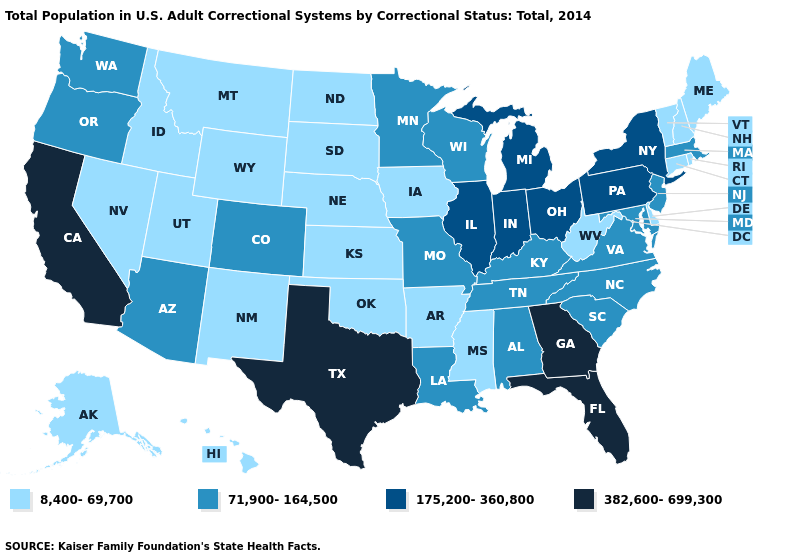What is the value of Florida?
Concise answer only. 382,600-699,300. What is the lowest value in the USA?
Concise answer only. 8,400-69,700. What is the lowest value in the South?
Concise answer only. 8,400-69,700. Which states have the lowest value in the MidWest?
Answer briefly. Iowa, Kansas, Nebraska, North Dakota, South Dakota. What is the value of Alabama?
Short answer required. 71,900-164,500. What is the value of Hawaii?
Be succinct. 8,400-69,700. What is the value of Mississippi?
Short answer required. 8,400-69,700. What is the highest value in states that border New Mexico?
Keep it brief. 382,600-699,300. Among the states that border Arizona , does California have the highest value?
Keep it brief. Yes. What is the highest value in the Northeast ?
Short answer required. 175,200-360,800. What is the value of Oklahoma?
Short answer required. 8,400-69,700. Does Montana have the lowest value in the USA?
Keep it brief. Yes. Among the states that border Oklahoma , which have the lowest value?
Quick response, please. Arkansas, Kansas, New Mexico. Does the first symbol in the legend represent the smallest category?
Be succinct. Yes. What is the value of North Dakota?
Concise answer only. 8,400-69,700. 